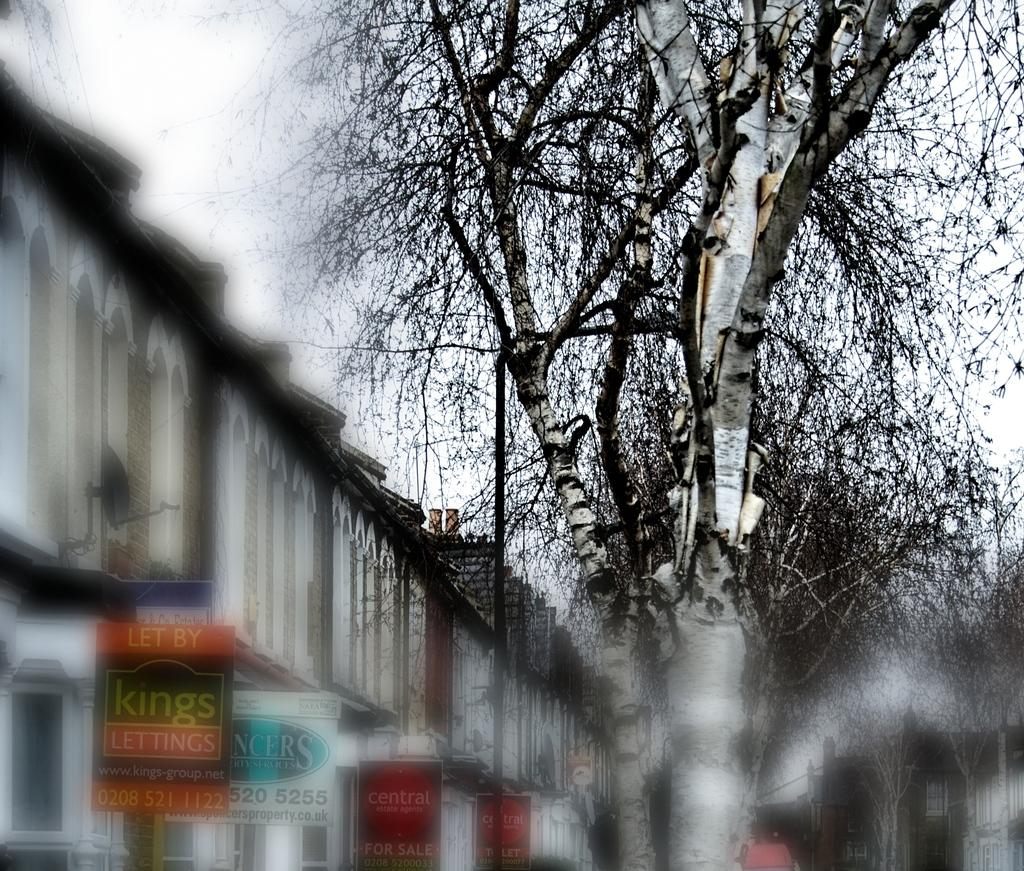Provide a one-sentence caption for the provided image. On a gloomy day the 3rd sign on the building says "Central Estate Agents For Sale". 